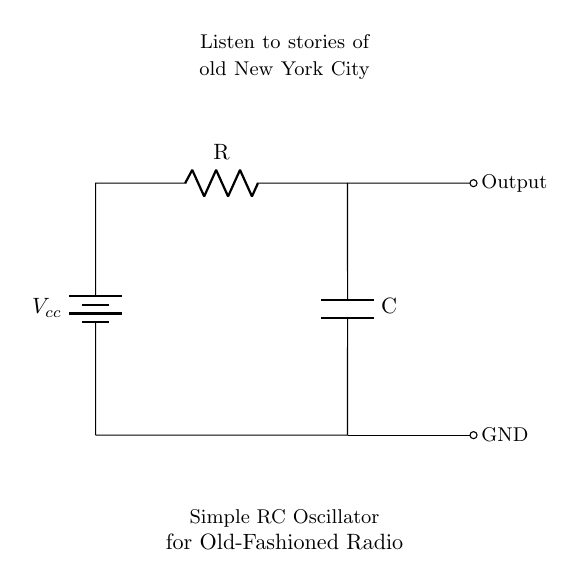What are the main components in this circuit? The main components are a resistor, a capacitor, and a battery. The battery provides the voltage, while the resistor and capacitor form the RC network that generates the oscillator signal.
Answer: resistor, capacitor, battery What is the function of the capacitor in this circuit? The capacitor stores and releases energy, which is crucial for the oscillation process. It allows the circuit to charge and discharge, creating the necessary feedback for oscillation.
Answer: energy storage What is the purpose of the resistor in the oscillator circuit? The resistor controls the charge and discharge timing of the capacitor. Its resistance value influences the frequency of oscillation by determining how quickly the capacitor charges and discharges.
Answer: timing control What type of signal does this oscillator produce? The oscillator produces a periodic signal, typically a square or sine wave. This periodicity is essential for generating the audio frequencies required for listening to stories on a radio.
Answer: periodic signal How does changing the values of R or C affect the oscillation frequency? Increasing the resistance or capacitance will decrease the oscillation frequency, while decreasing these values will increase the frequency. This relationship is described by the formula for the frequency of an RC oscillator, which involves both R and C.
Answer: frequency change 